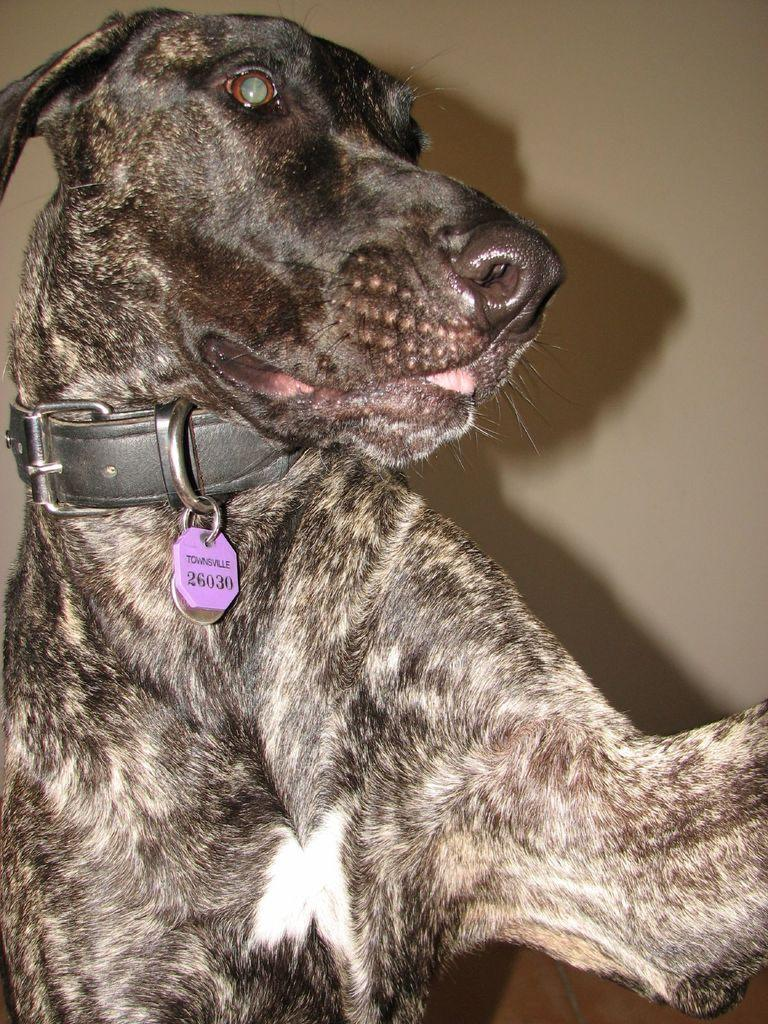What is the main subject in the center of the image? There is a dog in the center of the image. What can be seen in the background of the image? There is a wall in the background of the image. What type of relation does the dog have with the pail in the image? There is no pail present in the image, so the dog does not have any relation with a pail. 